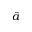<formula> <loc_0><loc_0><loc_500><loc_500>\hat { a }</formula> 